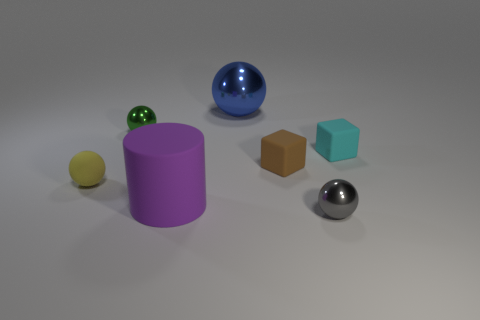Subtract all blue metal spheres. How many spheres are left? 3 Add 3 cyan matte objects. How many objects exist? 10 Subtract 1 balls. How many balls are left? 3 Subtract all blue balls. How many balls are left? 3 Subtract all balls. How many objects are left? 3 Subtract all big cyan shiny spheres. Subtract all brown objects. How many objects are left? 6 Add 1 matte things. How many matte things are left? 5 Add 5 tiny brown objects. How many tiny brown objects exist? 6 Subtract 0 brown balls. How many objects are left? 7 Subtract all red cylinders. Subtract all green blocks. How many cylinders are left? 1 